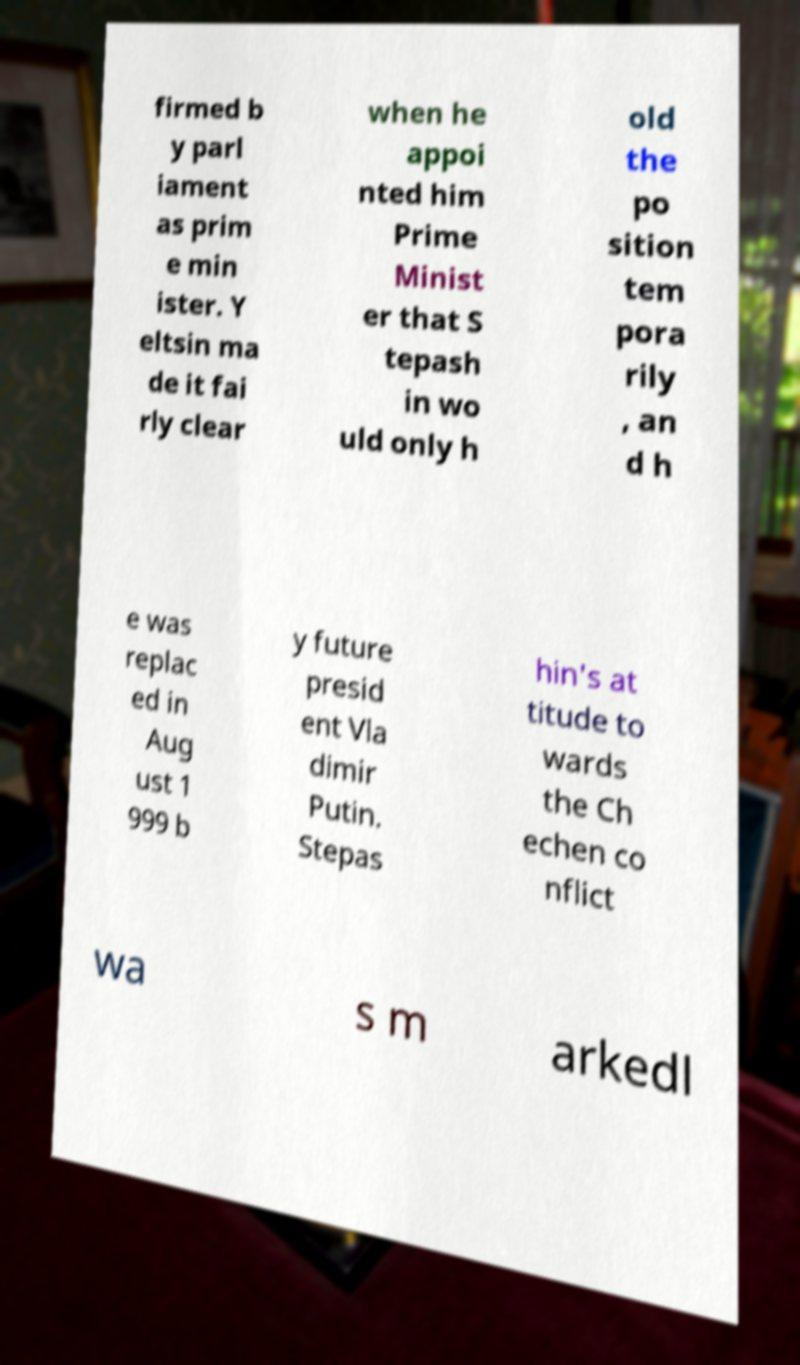Please read and relay the text visible in this image. What does it say? firmed b y parl iament as prim e min ister. Y eltsin ma de it fai rly clear when he appoi nted him Prime Minist er that S tepash in wo uld only h old the po sition tem pora rily , an d h e was replac ed in Aug ust 1 999 b y future presid ent Vla dimir Putin. Stepas hin's at titude to wards the Ch echen co nflict wa s m arkedl 